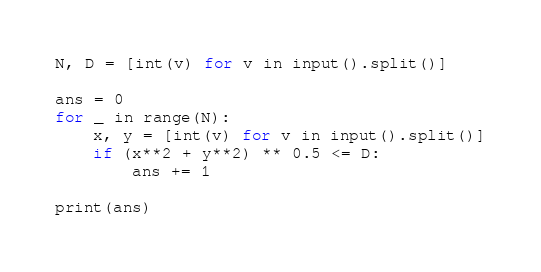Convert code to text. <code><loc_0><loc_0><loc_500><loc_500><_Python_>N, D = [int(v) for v in input().split()]

ans = 0
for _ in range(N):
    x, y = [int(v) for v in input().split()]
    if (x**2 + y**2) ** 0.5 <= D:
        ans += 1

print(ans)</code> 